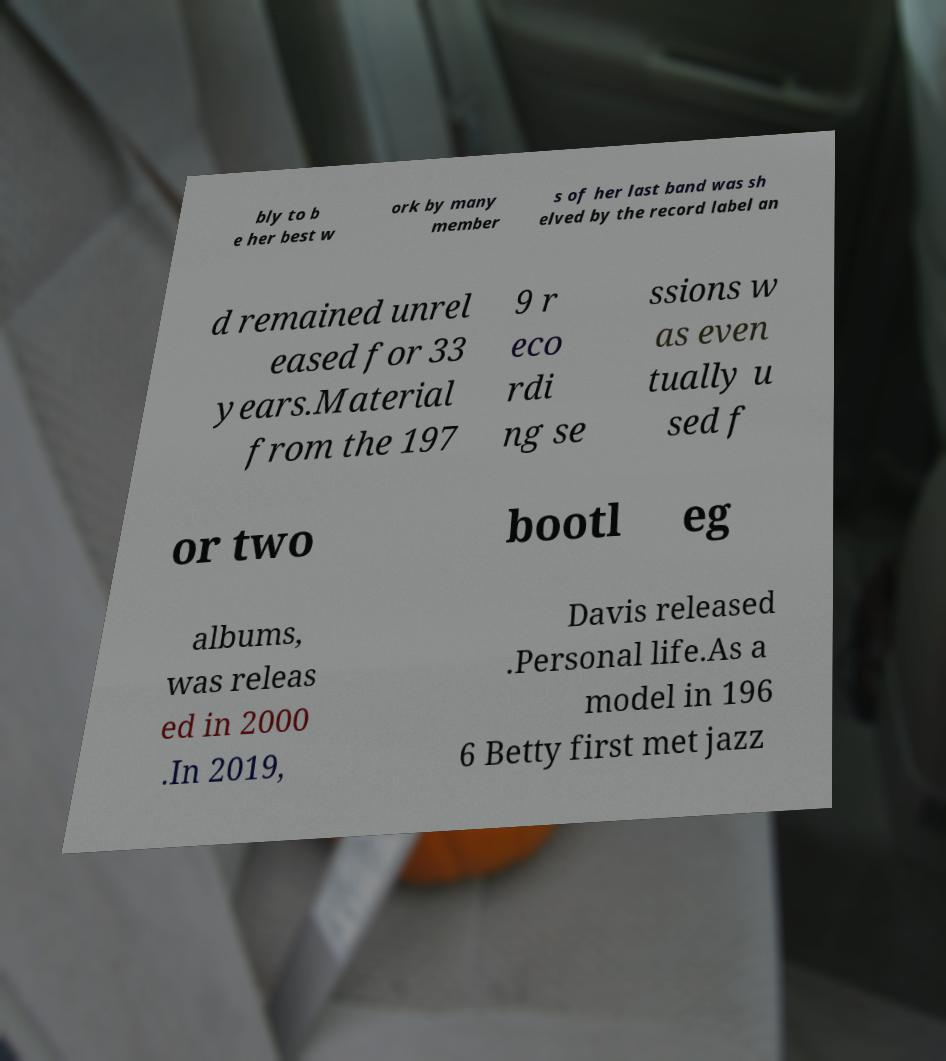What messages or text are displayed in this image? I need them in a readable, typed format. bly to b e her best w ork by many member s of her last band was sh elved by the record label an d remained unrel eased for 33 years.Material from the 197 9 r eco rdi ng se ssions w as even tually u sed f or two bootl eg albums, was releas ed in 2000 .In 2019, Davis released .Personal life.As a model in 196 6 Betty first met jazz 